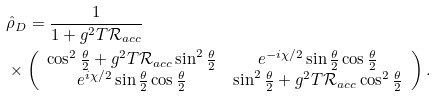<formula> <loc_0><loc_0><loc_500><loc_500>& \hat { \rho } _ { D } = \frac { 1 } { 1 + g ^ { 2 } T \mathcal { R } _ { a c c } } \\ & \times \left ( \begin{array} { c c } \cos ^ { 2 } \frac { \theta } { 2 } + g ^ { 2 } T \mathcal { R } _ { a c c } \sin ^ { 2 } \frac { \theta } { 2 } & e ^ { - i \chi / 2 } \sin \frac { \theta } { 2 } \cos \frac { \theta } { 2 } \\ e ^ { i \chi / 2 } \sin \frac { \theta } { 2 } \cos \frac { \theta } { 2 } & \sin ^ { 2 } \frac { \theta } { 2 } + g ^ { 2 } T \mathcal { R } _ { a c c } \cos ^ { 2 } \frac { \theta } { 2 } \end{array} \right ) .</formula> 